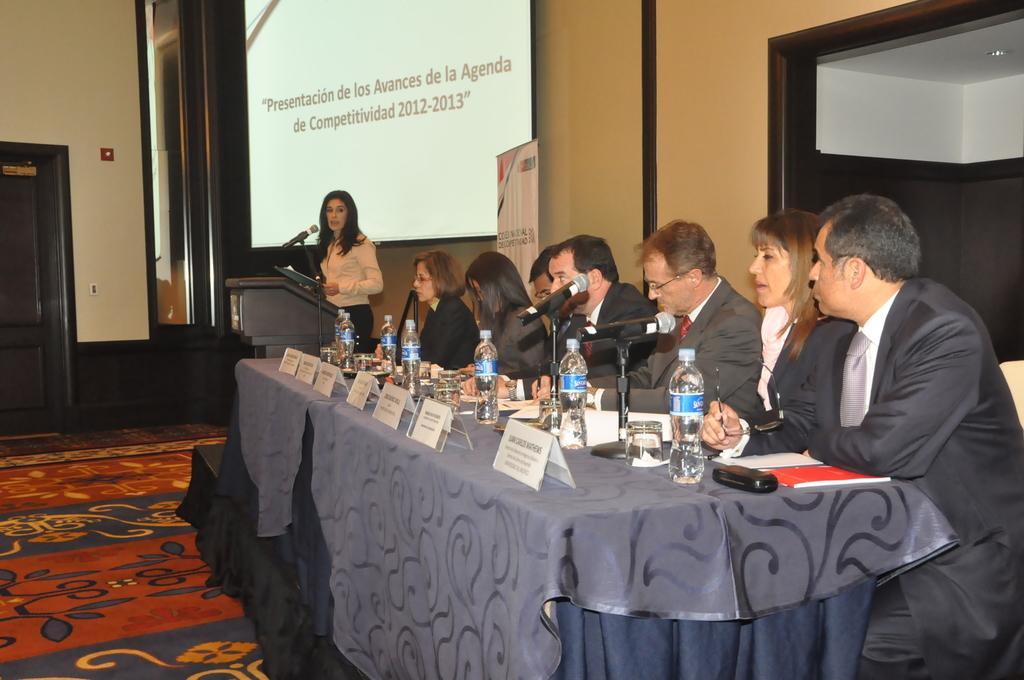How would you summarize this image in a sentence or two? There are few people sitting on the chairs. This is the table covered with cloth. These are the name boards,water bottles,glasses,mike's,papers and few things placed on the table. Here is the woman standing and speaking on the mike. This is the podium. This is the banner. Here is the screen hanging. This looks like a mirror. I can see a door. This is the carpet on the floor. 